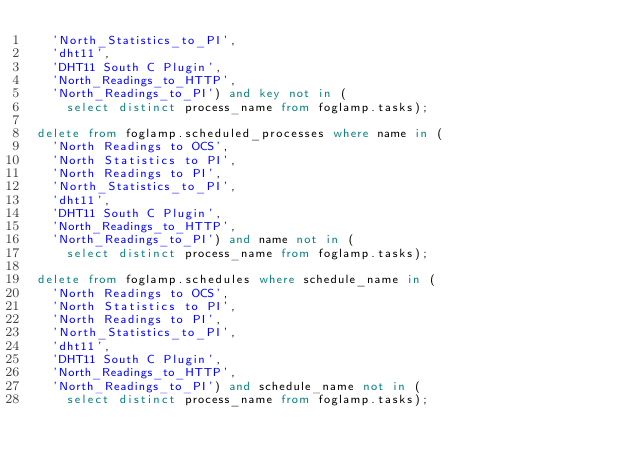<code> <loc_0><loc_0><loc_500><loc_500><_SQL_>	'North_Statistics_to_PI',
	'dht11',
	'DHT11 South C Plugin',
	'North_Readings_to_HTTP',
	'North_Readings_to_PI') and key not in (
		select distinct process_name from foglamp.tasks);

delete from foglamp.scheduled_processes where name in (
	'North Readings to OCS',
	'North Statistics to PI',
	'North Readings to PI',
	'North_Statistics_to_PI',
	'dht11',
	'DHT11 South C Plugin',
	'North_Readings_to_HTTP',
	'North_Readings_to_PI') and name not in (
		select distinct process_name from foglamp.tasks);

delete from foglamp.schedules where schedule_name in (
	'North Readings to OCS',
	'North Statistics to PI',
	'North Readings to PI',
	'North_Statistics_to_PI',
	'dht11',
	'DHT11 South C Plugin',
	'North_Readings_to_HTTP',
	'North_Readings_to_PI') and schedule_name not in (
		select distinct process_name from foglamp.tasks);

</code> 